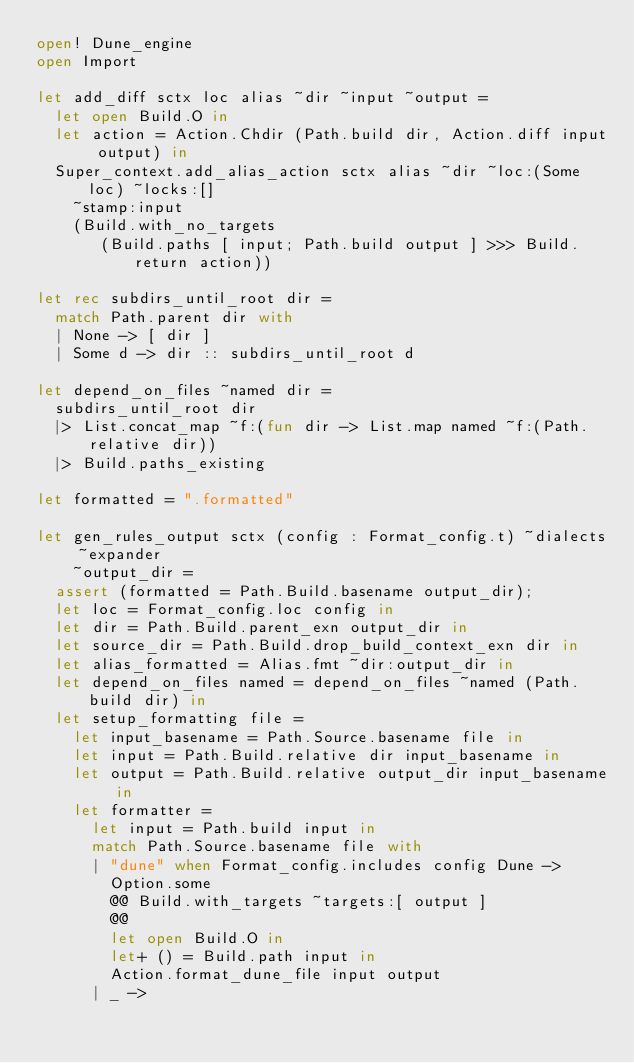<code> <loc_0><loc_0><loc_500><loc_500><_OCaml_>open! Dune_engine
open Import

let add_diff sctx loc alias ~dir ~input ~output =
  let open Build.O in
  let action = Action.Chdir (Path.build dir, Action.diff input output) in
  Super_context.add_alias_action sctx alias ~dir ~loc:(Some loc) ~locks:[]
    ~stamp:input
    (Build.with_no_targets
       (Build.paths [ input; Path.build output ] >>> Build.return action))

let rec subdirs_until_root dir =
  match Path.parent dir with
  | None -> [ dir ]
  | Some d -> dir :: subdirs_until_root d

let depend_on_files ~named dir =
  subdirs_until_root dir
  |> List.concat_map ~f:(fun dir -> List.map named ~f:(Path.relative dir))
  |> Build.paths_existing

let formatted = ".formatted"

let gen_rules_output sctx (config : Format_config.t) ~dialects ~expander
    ~output_dir =
  assert (formatted = Path.Build.basename output_dir);
  let loc = Format_config.loc config in
  let dir = Path.Build.parent_exn output_dir in
  let source_dir = Path.Build.drop_build_context_exn dir in
  let alias_formatted = Alias.fmt ~dir:output_dir in
  let depend_on_files named = depend_on_files ~named (Path.build dir) in
  let setup_formatting file =
    let input_basename = Path.Source.basename file in
    let input = Path.Build.relative dir input_basename in
    let output = Path.Build.relative output_dir input_basename in
    let formatter =
      let input = Path.build input in
      match Path.Source.basename file with
      | "dune" when Format_config.includes config Dune ->
        Option.some
        @@ Build.with_targets ~targets:[ output ]
        @@
        let open Build.O in
        let+ () = Build.path input in
        Action.format_dune_file input output
      | _ -></code> 